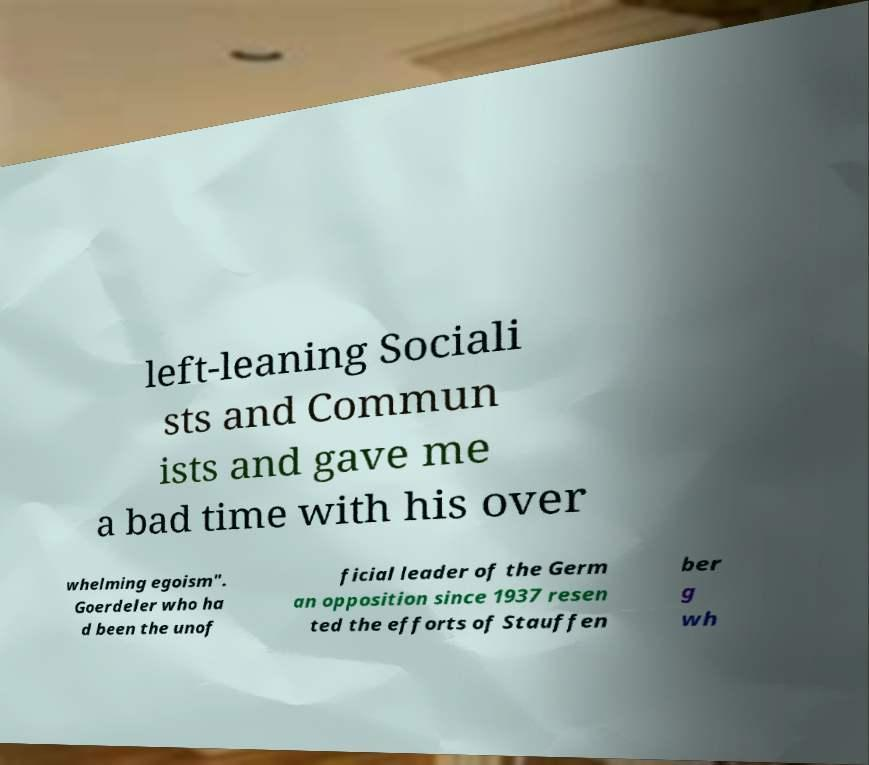Please identify and transcribe the text found in this image. left-leaning Sociali sts and Commun ists and gave me a bad time with his over whelming egoism". Goerdeler who ha d been the unof ficial leader of the Germ an opposition since 1937 resen ted the efforts of Stauffen ber g wh 